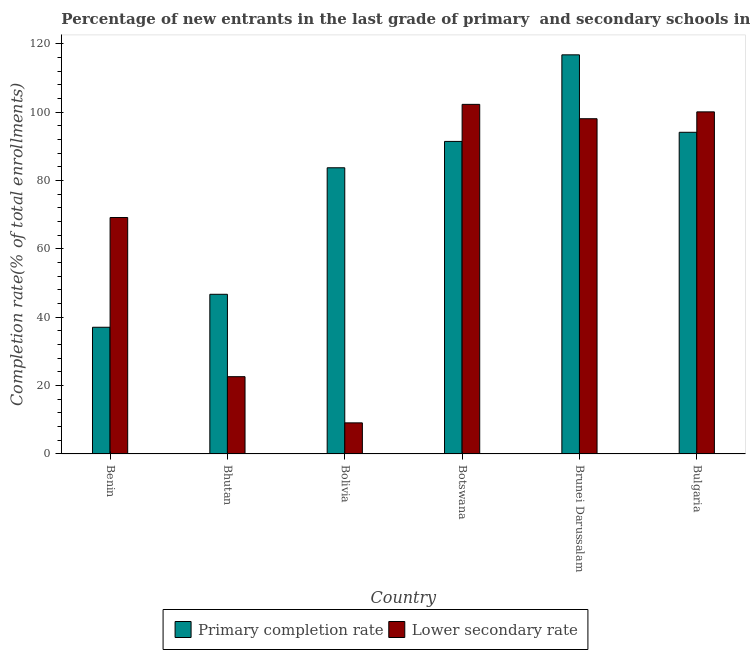How many different coloured bars are there?
Ensure brevity in your answer.  2. How many groups of bars are there?
Ensure brevity in your answer.  6. How many bars are there on the 4th tick from the left?
Your answer should be very brief. 2. What is the label of the 5th group of bars from the left?
Your answer should be very brief. Brunei Darussalam. In how many cases, is the number of bars for a given country not equal to the number of legend labels?
Provide a short and direct response. 0. What is the completion rate in primary schools in Bhutan?
Your response must be concise. 46.72. Across all countries, what is the maximum completion rate in secondary schools?
Your answer should be compact. 102.28. Across all countries, what is the minimum completion rate in secondary schools?
Ensure brevity in your answer.  9.1. In which country was the completion rate in primary schools maximum?
Provide a short and direct response. Brunei Darussalam. In which country was the completion rate in primary schools minimum?
Make the answer very short. Benin. What is the total completion rate in primary schools in the graph?
Make the answer very short. 469.84. What is the difference between the completion rate in primary schools in Brunei Darussalam and that in Bulgaria?
Your answer should be very brief. 22.66. What is the difference between the completion rate in secondary schools in Botswana and the completion rate in primary schools in Bhutan?
Your response must be concise. 55.56. What is the average completion rate in primary schools per country?
Provide a succinct answer. 78.31. What is the difference between the completion rate in primary schools and completion rate in secondary schools in Benin?
Your answer should be compact. -32.1. In how many countries, is the completion rate in secondary schools greater than 40 %?
Offer a very short reply. 4. What is the ratio of the completion rate in primary schools in Brunei Darussalam to that in Bulgaria?
Offer a terse response. 1.24. Is the completion rate in primary schools in Bhutan less than that in Bolivia?
Ensure brevity in your answer.  Yes. Is the difference between the completion rate in primary schools in Benin and Bulgaria greater than the difference between the completion rate in secondary schools in Benin and Bulgaria?
Keep it short and to the point. No. What is the difference between the highest and the second highest completion rate in primary schools?
Your answer should be very brief. 22.66. What is the difference between the highest and the lowest completion rate in primary schools?
Provide a succinct answer. 79.7. What does the 2nd bar from the left in Brunei Darussalam represents?
Provide a succinct answer. Lower secondary rate. What does the 1st bar from the right in Brunei Darussalam represents?
Provide a short and direct response. Lower secondary rate. How many bars are there?
Make the answer very short. 12. How many countries are there in the graph?
Offer a terse response. 6. How many legend labels are there?
Your response must be concise. 2. What is the title of the graph?
Make the answer very short. Percentage of new entrants in the last grade of primary  and secondary schools in countries. What is the label or title of the Y-axis?
Give a very brief answer. Completion rate(% of total enrollments). What is the Completion rate(% of total enrollments) in Primary completion rate in Benin?
Your answer should be compact. 37.07. What is the Completion rate(% of total enrollments) of Lower secondary rate in Benin?
Provide a succinct answer. 69.17. What is the Completion rate(% of total enrollments) of Primary completion rate in Bhutan?
Ensure brevity in your answer.  46.72. What is the Completion rate(% of total enrollments) of Lower secondary rate in Bhutan?
Your response must be concise. 22.61. What is the Completion rate(% of total enrollments) of Primary completion rate in Bolivia?
Your response must be concise. 83.73. What is the Completion rate(% of total enrollments) in Lower secondary rate in Bolivia?
Make the answer very short. 9.1. What is the Completion rate(% of total enrollments) of Primary completion rate in Botswana?
Offer a terse response. 91.44. What is the Completion rate(% of total enrollments) of Lower secondary rate in Botswana?
Make the answer very short. 102.28. What is the Completion rate(% of total enrollments) of Primary completion rate in Brunei Darussalam?
Ensure brevity in your answer.  116.77. What is the Completion rate(% of total enrollments) of Lower secondary rate in Brunei Darussalam?
Keep it short and to the point. 98.08. What is the Completion rate(% of total enrollments) of Primary completion rate in Bulgaria?
Make the answer very short. 94.11. What is the Completion rate(% of total enrollments) of Lower secondary rate in Bulgaria?
Your answer should be compact. 100.08. Across all countries, what is the maximum Completion rate(% of total enrollments) in Primary completion rate?
Keep it short and to the point. 116.77. Across all countries, what is the maximum Completion rate(% of total enrollments) in Lower secondary rate?
Your answer should be compact. 102.28. Across all countries, what is the minimum Completion rate(% of total enrollments) in Primary completion rate?
Offer a very short reply. 37.07. Across all countries, what is the minimum Completion rate(% of total enrollments) in Lower secondary rate?
Give a very brief answer. 9.1. What is the total Completion rate(% of total enrollments) in Primary completion rate in the graph?
Your response must be concise. 469.84. What is the total Completion rate(% of total enrollments) in Lower secondary rate in the graph?
Give a very brief answer. 401.33. What is the difference between the Completion rate(% of total enrollments) in Primary completion rate in Benin and that in Bhutan?
Ensure brevity in your answer.  -9.65. What is the difference between the Completion rate(% of total enrollments) of Lower secondary rate in Benin and that in Bhutan?
Your answer should be compact. 46.56. What is the difference between the Completion rate(% of total enrollments) of Primary completion rate in Benin and that in Bolivia?
Ensure brevity in your answer.  -46.66. What is the difference between the Completion rate(% of total enrollments) in Lower secondary rate in Benin and that in Bolivia?
Your answer should be compact. 60.07. What is the difference between the Completion rate(% of total enrollments) in Primary completion rate in Benin and that in Botswana?
Keep it short and to the point. -54.37. What is the difference between the Completion rate(% of total enrollments) in Lower secondary rate in Benin and that in Botswana?
Offer a terse response. -33.11. What is the difference between the Completion rate(% of total enrollments) of Primary completion rate in Benin and that in Brunei Darussalam?
Your answer should be compact. -79.7. What is the difference between the Completion rate(% of total enrollments) of Lower secondary rate in Benin and that in Brunei Darussalam?
Offer a terse response. -28.91. What is the difference between the Completion rate(% of total enrollments) in Primary completion rate in Benin and that in Bulgaria?
Your response must be concise. -57.04. What is the difference between the Completion rate(% of total enrollments) in Lower secondary rate in Benin and that in Bulgaria?
Keep it short and to the point. -30.91. What is the difference between the Completion rate(% of total enrollments) in Primary completion rate in Bhutan and that in Bolivia?
Your answer should be compact. -37.01. What is the difference between the Completion rate(% of total enrollments) of Lower secondary rate in Bhutan and that in Bolivia?
Make the answer very short. 13.51. What is the difference between the Completion rate(% of total enrollments) of Primary completion rate in Bhutan and that in Botswana?
Offer a very short reply. -44.72. What is the difference between the Completion rate(% of total enrollments) in Lower secondary rate in Bhutan and that in Botswana?
Your answer should be very brief. -79.66. What is the difference between the Completion rate(% of total enrollments) in Primary completion rate in Bhutan and that in Brunei Darussalam?
Your answer should be very brief. -70.05. What is the difference between the Completion rate(% of total enrollments) in Lower secondary rate in Bhutan and that in Brunei Darussalam?
Make the answer very short. -75.46. What is the difference between the Completion rate(% of total enrollments) in Primary completion rate in Bhutan and that in Bulgaria?
Make the answer very short. -47.4. What is the difference between the Completion rate(% of total enrollments) in Lower secondary rate in Bhutan and that in Bulgaria?
Provide a succinct answer. -77.47. What is the difference between the Completion rate(% of total enrollments) in Primary completion rate in Bolivia and that in Botswana?
Provide a short and direct response. -7.71. What is the difference between the Completion rate(% of total enrollments) in Lower secondary rate in Bolivia and that in Botswana?
Offer a terse response. -93.18. What is the difference between the Completion rate(% of total enrollments) in Primary completion rate in Bolivia and that in Brunei Darussalam?
Offer a very short reply. -33.04. What is the difference between the Completion rate(% of total enrollments) of Lower secondary rate in Bolivia and that in Brunei Darussalam?
Provide a short and direct response. -88.98. What is the difference between the Completion rate(% of total enrollments) in Primary completion rate in Bolivia and that in Bulgaria?
Ensure brevity in your answer.  -10.38. What is the difference between the Completion rate(% of total enrollments) of Lower secondary rate in Bolivia and that in Bulgaria?
Your answer should be very brief. -90.98. What is the difference between the Completion rate(% of total enrollments) in Primary completion rate in Botswana and that in Brunei Darussalam?
Give a very brief answer. -25.33. What is the difference between the Completion rate(% of total enrollments) of Lower secondary rate in Botswana and that in Brunei Darussalam?
Provide a short and direct response. 4.2. What is the difference between the Completion rate(% of total enrollments) in Primary completion rate in Botswana and that in Bulgaria?
Provide a short and direct response. -2.67. What is the difference between the Completion rate(% of total enrollments) of Lower secondary rate in Botswana and that in Bulgaria?
Your answer should be compact. 2.2. What is the difference between the Completion rate(% of total enrollments) in Primary completion rate in Brunei Darussalam and that in Bulgaria?
Provide a short and direct response. 22.66. What is the difference between the Completion rate(% of total enrollments) of Lower secondary rate in Brunei Darussalam and that in Bulgaria?
Give a very brief answer. -2. What is the difference between the Completion rate(% of total enrollments) of Primary completion rate in Benin and the Completion rate(% of total enrollments) of Lower secondary rate in Bhutan?
Your answer should be very brief. 14.46. What is the difference between the Completion rate(% of total enrollments) in Primary completion rate in Benin and the Completion rate(% of total enrollments) in Lower secondary rate in Bolivia?
Ensure brevity in your answer.  27.97. What is the difference between the Completion rate(% of total enrollments) of Primary completion rate in Benin and the Completion rate(% of total enrollments) of Lower secondary rate in Botswana?
Your answer should be compact. -65.21. What is the difference between the Completion rate(% of total enrollments) of Primary completion rate in Benin and the Completion rate(% of total enrollments) of Lower secondary rate in Brunei Darussalam?
Keep it short and to the point. -61.01. What is the difference between the Completion rate(% of total enrollments) of Primary completion rate in Benin and the Completion rate(% of total enrollments) of Lower secondary rate in Bulgaria?
Your answer should be very brief. -63.01. What is the difference between the Completion rate(% of total enrollments) in Primary completion rate in Bhutan and the Completion rate(% of total enrollments) in Lower secondary rate in Bolivia?
Ensure brevity in your answer.  37.62. What is the difference between the Completion rate(% of total enrollments) in Primary completion rate in Bhutan and the Completion rate(% of total enrollments) in Lower secondary rate in Botswana?
Ensure brevity in your answer.  -55.56. What is the difference between the Completion rate(% of total enrollments) of Primary completion rate in Bhutan and the Completion rate(% of total enrollments) of Lower secondary rate in Brunei Darussalam?
Offer a very short reply. -51.36. What is the difference between the Completion rate(% of total enrollments) in Primary completion rate in Bhutan and the Completion rate(% of total enrollments) in Lower secondary rate in Bulgaria?
Make the answer very short. -53.37. What is the difference between the Completion rate(% of total enrollments) of Primary completion rate in Bolivia and the Completion rate(% of total enrollments) of Lower secondary rate in Botswana?
Ensure brevity in your answer.  -18.55. What is the difference between the Completion rate(% of total enrollments) of Primary completion rate in Bolivia and the Completion rate(% of total enrollments) of Lower secondary rate in Brunei Darussalam?
Your answer should be very brief. -14.35. What is the difference between the Completion rate(% of total enrollments) in Primary completion rate in Bolivia and the Completion rate(% of total enrollments) in Lower secondary rate in Bulgaria?
Make the answer very short. -16.35. What is the difference between the Completion rate(% of total enrollments) of Primary completion rate in Botswana and the Completion rate(% of total enrollments) of Lower secondary rate in Brunei Darussalam?
Provide a short and direct response. -6.64. What is the difference between the Completion rate(% of total enrollments) of Primary completion rate in Botswana and the Completion rate(% of total enrollments) of Lower secondary rate in Bulgaria?
Ensure brevity in your answer.  -8.64. What is the difference between the Completion rate(% of total enrollments) in Primary completion rate in Brunei Darussalam and the Completion rate(% of total enrollments) in Lower secondary rate in Bulgaria?
Provide a succinct answer. 16.69. What is the average Completion rate(% of total enrollments) of Primary completion rate per country?
Provide a short and direct response. 78.31. What is the average Completion rate(% of total enrollments) of Lower secondary rate per country?
Give a very brief answer. 66.89. What is the difference between the Completion rate(% of total enrollments) of Primary completion rate and Completion rate(% of total enrollments) of Lower secondary rate in Benin?
Give a very brief answer. -32.1. What is the difference between the Completion rate(% of total enrollments) of Primary completion rate and Completion rate(% of total enrollments) of Lower secondary rate in Bhutan?
Provide a short and direct response. 24.1. What is the difference between the Completion rate(% of total enrollments) of Primary completion rate and Completion rate(% of total enrollments) of Lower secondary rate in Bolivia?
Give a very brief answer. 74.63. What is the difference between the Completion rate(% of total enrollments) in Primary completion rate and Completion rate(% of total enrollments) in Lower secondary rate in Botswana?
Give a very brief answer. -10.84. What is the difference between the Completion rate(% of total enrollments) of Primary completion rate and Completion rate(% of total enrollments) of Lower secondary rate in Brunei Darussalam?
Provide a short and direct response. 18.69. What is the difference between the Completion rate(% of total enrollments) of Primary completion rate and Completion rate(% of total enrollments) of Lower secondary rate in Bulgaria?
Ensure brevity in your answer.  -5.97. What is the ratio of the Completion rate(% of total enrollments) of Primary completion rate in Benin to that in Bhutan?
Keep it short and to the point. 0.79. What is the ratio of the Completion rate(% of total enrollments) in Lower secondary rate in Benin to that in Bhutan?
Keep it short and to the point. 3.06. What is the ratio of the Completion rate(% of total enrollments) in Primary completion rate in Benin to that in Bolivia?
Offer a terse response. 0.44. What is the ratio of the Completion rate(% of total enrollments) of Lower secondary rate in Benin to that in Bolivia?
Your answer should be very brief. 7.6. What is the ratio of the Completion rate(% of total enrollments) of Primary completion rate in Benin to that in Botswana?
Provide a short and direct response. 0.41. What is the ratio of the Completion rate(% of total enrollments) in Lower secondary rate in Benin to that in Botswana?
Your answer should be very brief. 0.68. What is the ratio of the Completion rate(% of total enrollments) of Primary completion rate in Benin to that in Brunei Darussalam?
Your answer should be very brief. 0.32. What is the ratio of the Completion rate(% of total enrollments) in Lower secondary rate in Benin to that in Brunei Darussalam?
Make the answer very short. 0.71. What is the ratio of the Completion rate(% of total enrollments) of Primary completion rate in Benin to that in Bulgaria?
Offer a terse response. 0.39. What is the ratio of the Completion rate(% of total enrollments) in Lower secondary rate in Benin to that in Bulgaria?
Offer a terse response. 0.69. What is the ratio of the Completion rate(% of total enrollments) of Primary completion rate in Bhutan to that in Bolivia?
Keep it short and to the point. 0.56. What is the ratio of the Completion rate(% of total enrollments) of Lower secondary rate in Bhutan to that in Bolivia?
Give a very brief answer. 2.48. What is the ratio of the Completion rate(% of total enrollments) in Primary completion rate in Bhutan to that in Botswana?
Give a very brief answer. 0.51. What is the ratio of the Completion rate(% of total enrollments) in Lower secondary rate in Bhutan to that in Botswana?
Make the answer very short. 0.22. What is the ratio of the Completion rate(% of total enrollments) in Primary completion rate in Bhutan to that in Brunei Darussalam?
Keep it short and to the point. 0.4. What is the ratio of the Completion rate(% of total enrollments) of Lower secondary rate in Bhutan to that in Brunei Darussalam?
Your answer should be very brief. 0.23. What is the ratio of the Completion rate(% of total enrollments) of Primary completion rate in Bhutan to that in Bulgaria?
Make the answer very short. 0.5. What is the ratio of the Completion rate(% of total enrollments) of Lower secondary rate in Bhutan to that in Bulgaria?
Provide a succinct answer. 0.23. What is the ratio of the Completion rate(% of total enrollments) in Primary completion rate in Bolivia to that in Botswana?
Provide a succinct answer. 0.92. What is the ratio of the Completion rate(% of total enrollments) in Lower secondary rate in Bolivia to that in Botswana?
Your response must be concise. 0.09. What is the ratio of the Completion rate(% of total enrollments) of Primary completion rate in Bolivia to that in Brunei Darussalam?
Offer a terse response. 0.72. What is the ratio of the Completion rate(% of total enrollments) in Lower secondary rate in Bolivia to that in Brunei Darussalam?
Ensure brevity in your answer.  0.09. What is the ratio of the Completion rate(% of total enrollments) in Primary completion rate in Bolivia to that in Bulgaria?
Offer a very short reply. 0.89. What is the ratio of the Completion rate(% of total enrollments) of Lower secondary rate in Bolivia to that in Bulgaria?
Make the answer very short. 0.09. What is the ratio of the Completion rate(% of total enrollments) of Primary completion rate in Botswana to that in Brunei Darussalam?
Give a very brief answer. 0.78. What is the ratio of the Completion rate(% of total enrollments) in Lower secondary rate in Botswana to that in Brunei Darussalam?
Offer a terse response. 1.04. What is the ratio of the Completion rate(% of total enrollments) in Primary completion rate in Botswana to that in Bulgaria?
Offer a terse response. 0.97. What is the ratio of the Completion rate(% of total enrollments) in Lower secondary rate in Botswana to that in Bulgaria?
Ensure brevity in your answer.  1.02. What is the ratio of the Completion rate(% of total enrollments) of Primary completion rate in Brunei Darussalam to that in Bulgaria?
Your answer should be compact. 1.24. What is the ratio of the Completion rate(% of total enrollments) in Lower secondary rate in Brunei Darussalam to that in Bulgaria?
Offer a terse response. 0.98. What is the difference between the highest and the second highest Completion rate(% of total enrollments) of Primary completion rate?
Offer a terse response. 22.66. What is the difference between the highest and the second highest Completion rate(% of total enrollments) in Lower secondary rate?
Provide a short and direct response. 2.2. What is the difference between the highest and the lowest Completion rate(% of total enrollments) in Primary completion rate?
Provide a succinct answer. 79.7. What is the difference between the highest and the lowest Completion rate(% of total enrollments) of Lower secondary rate?
Offer a very short reply. 93.18. 